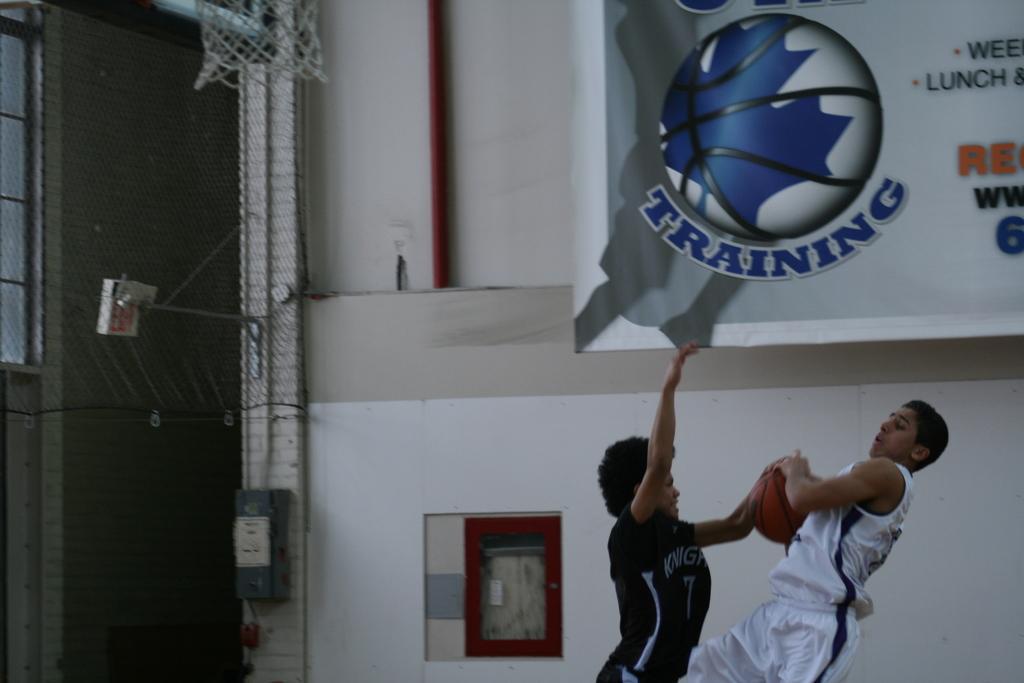How would you summarize this image in a sentence or two? In this image we can see this two persons are holding a ball in their hands. In the background we can see a banner and a net. 